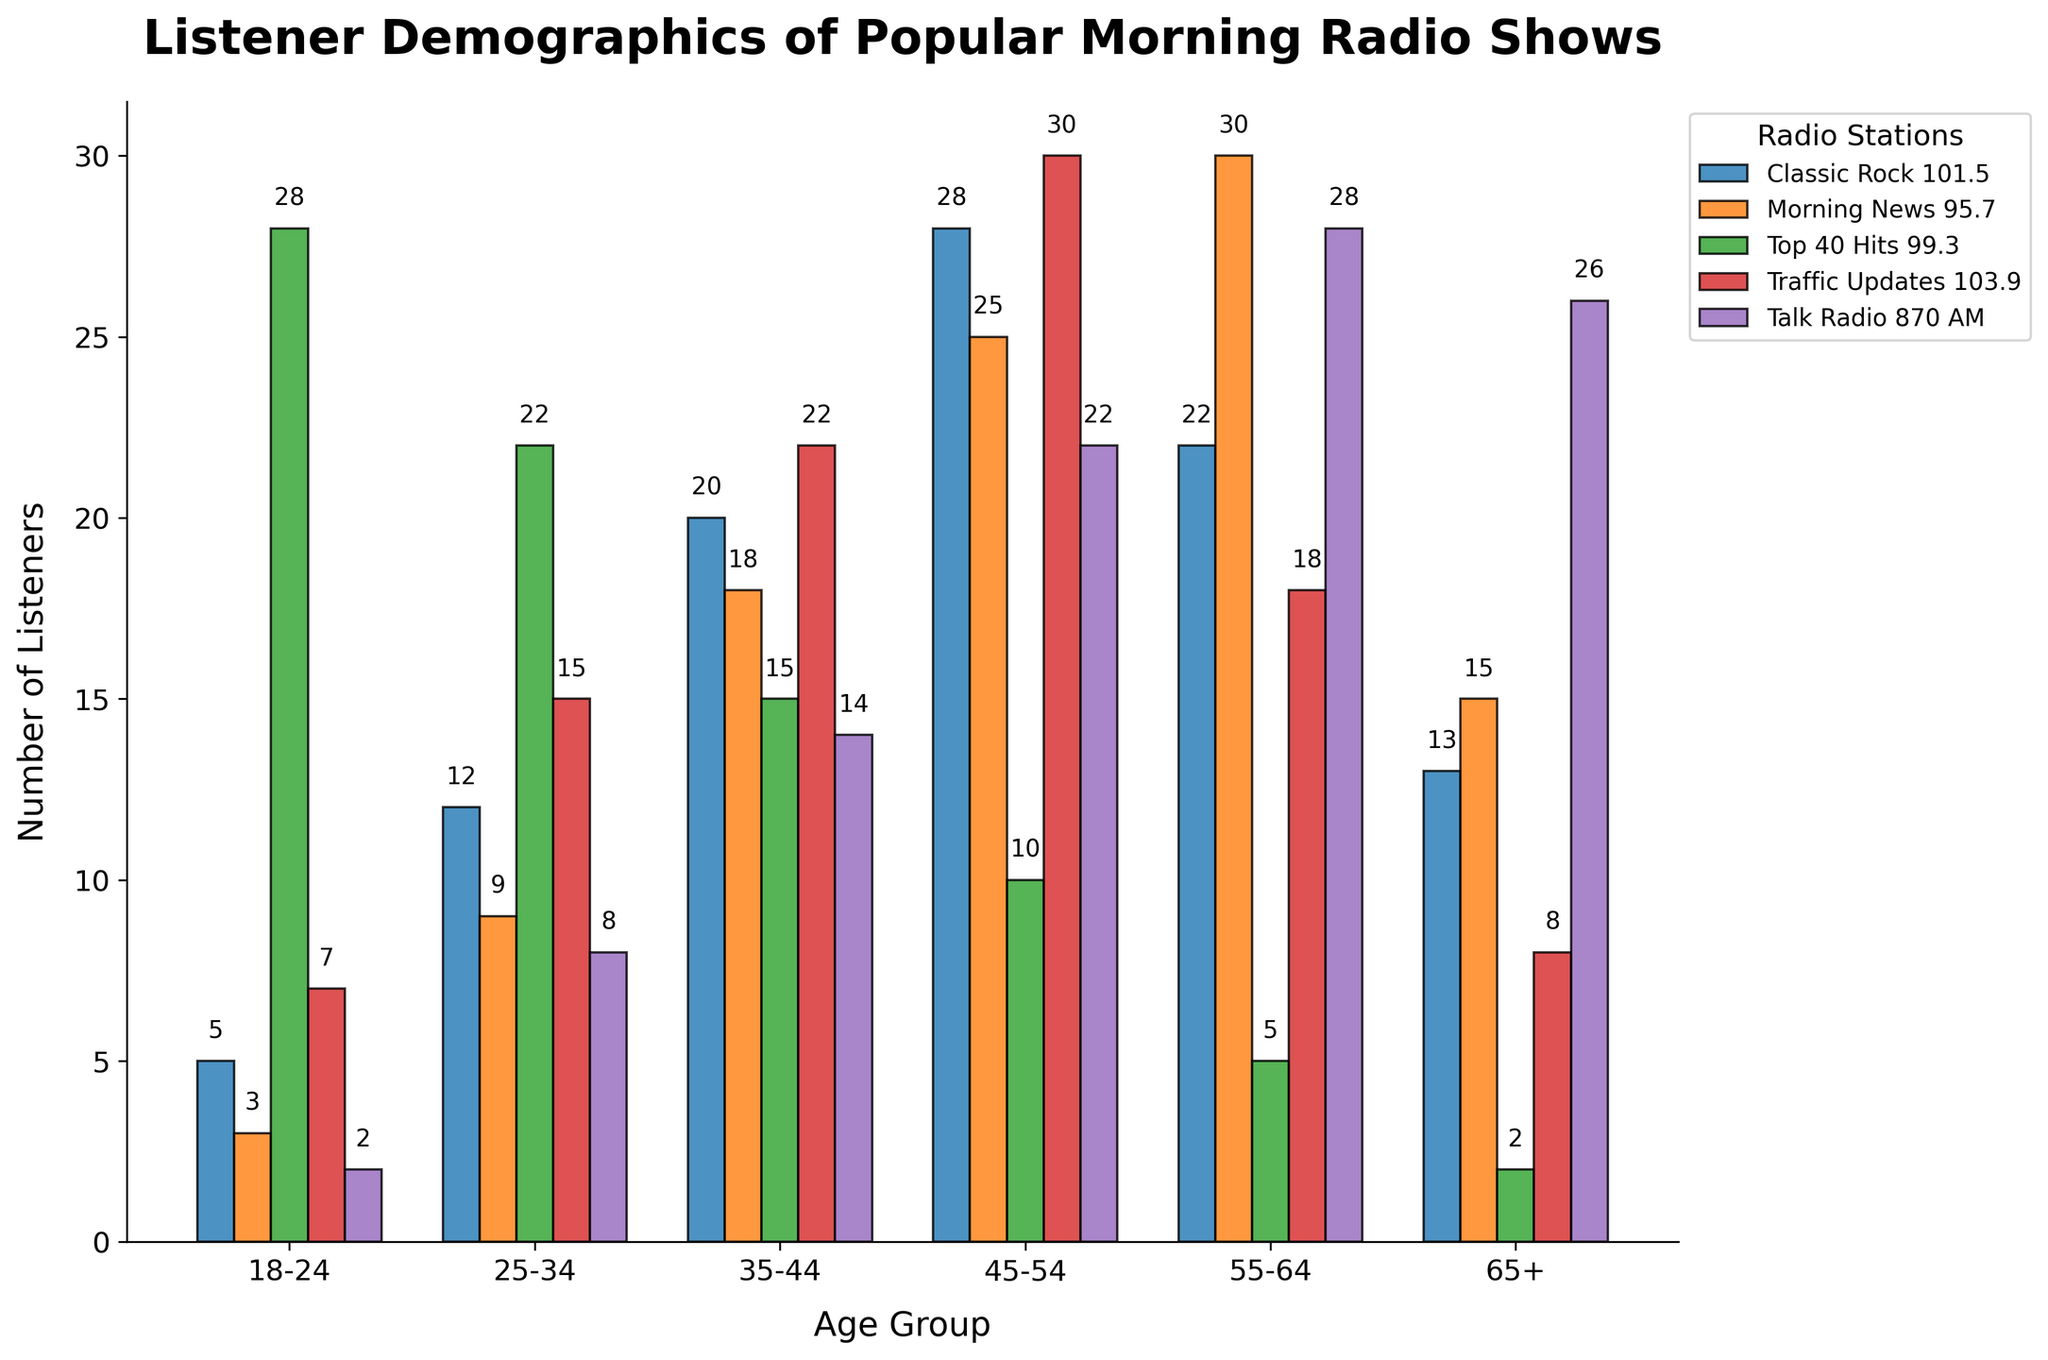Which age group listens to Top 40 Hits 99.3 the most? The chart shows the distribution of listeners across different age groups for Top 40 Hits 99.3. The tallest bar for Top 40 Hits 99.3 corresponds to the 18-24 age group with 28 listeners.
Answer: 18-24 Which radio station has the highest number of listeners among the 45-54 age group? The chart displays the number of listeners for each radio station across different age groups. The tallest bar within the 45-54 age group is for Traffic Updates 103.9, which has 30 listeners.
Answer: Traffic Updates 103.9 Compare the number of listeners between Classic Rock 101.5 and Talk Radio 870 AM for the 55-64 age group. Which has more listeners? The chart shows the values for Classic Rock 101.5 and Talk Radio 870 AM within the 55-64 age group. Classic Rock 101.5 has 22 listeners, and Talk Radio 870 AM has 28 listeners. Thus, Talk Radio 870 AM has more listeners in this age group.
Answer: Talk Radio 870 AM Which radio station appears to be the least popular among the 18-24 age group? By examining the bars corresponding to the 18-24 age group, the smallest bar is for Talk Radio 870 AM, which has only 2 listeners.
Answer: Talk Radio 870 AM What is the combined total of listeners for Morning News 95.7 in the 25-34 and 35-44 age groups? The chart shows 9 listeners for Morning News 95.7 in the 25-34 age group and 18 listeners in the 35-44 age group. Combining these values, the total is 9 + 18 = 27.
Answer: 27 Which age group has the highest number of listeners tuning into Talk Radio 870 AM? The tallest bar for Talk Radio 870 AM is in the 55-64 age group with 28 listeners.
Answer: 55-64 Compare the listener numbers for Traffic Updates 103.9 between the 25-34 and 35-44 age groups. Which has more listeners? The chart shows that Traffic Updates 103.9 has 15 listeners in the 25-34 age group and 22 listeners in the 35-44 age group. Thus, the 35-44 age group has more listeners.
Answer: 35-44 What is the sum of listeners for Classic Rock 101.5 and Morning News 95.7 among the 65+ age group? The chart shows 13 listeners for Classic Rock 101.5 and 15 listeners for Morning News 95.7 in the 65+ age group. Summing these values gives 13 + 15 = 28.
Answer: 28 Identify the radio station that has the lowest listener count among the 35-44 age group. By analyzing the bars within the 35-44 age group, the shortest bar is for Top 40 Hits 99.3, which has 15 listeners.
Answer: Top 40 Hits 99.3 